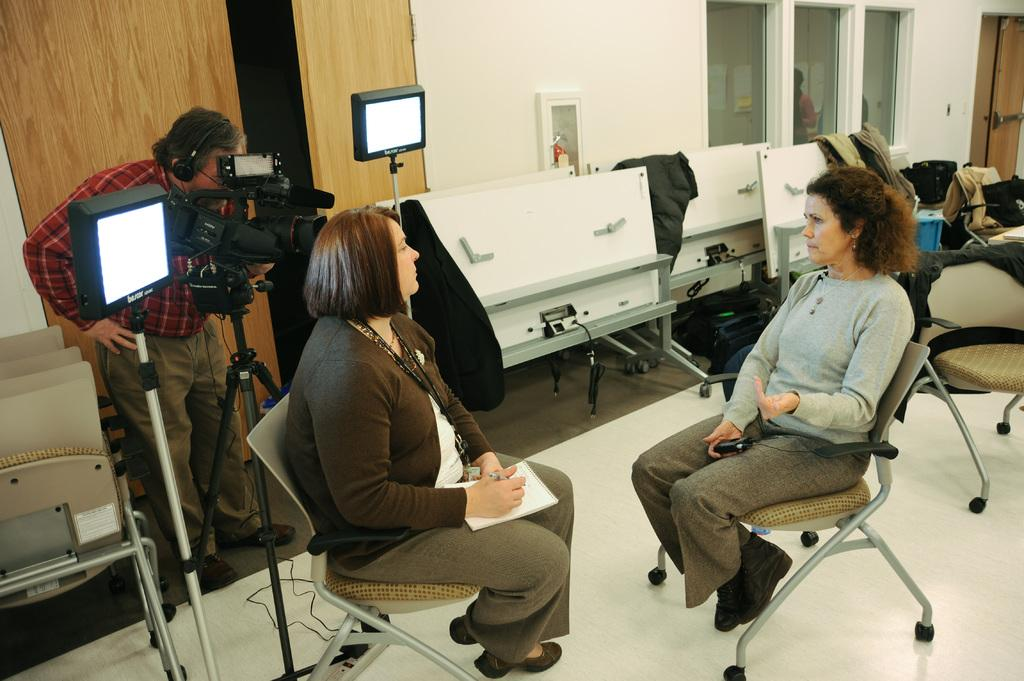How many women are present in the image? There are two women in the image. What are the women doing in the image? The women are sitting in front of each other, and it appears to be a TV interview. Who else is present in the image? There is a man in the background of the image. What is the man doing in the image? The man is looking through the camera. What type of metal is used to build the border around the TV interview set? There is no information about the border or the materials used to build it in the image. 